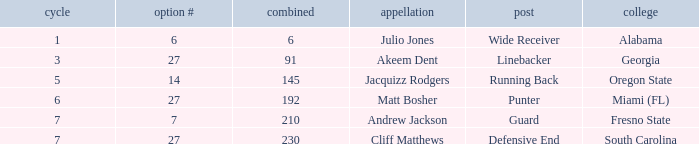Which name had more than 5 rounds and was a defensive end? Cliff Matthews. 